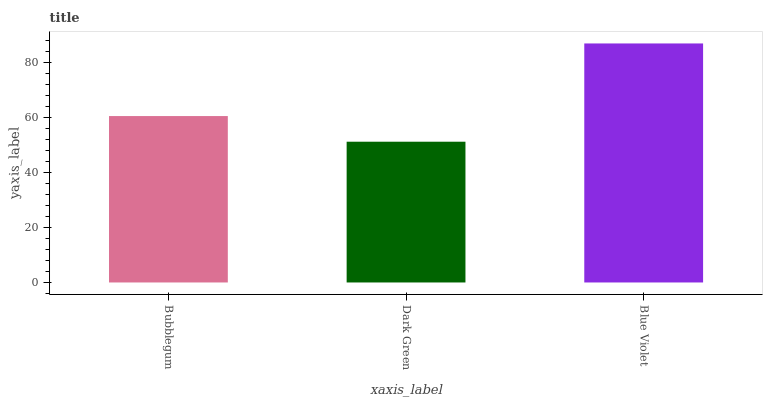Is Blue Violet the minimum?
Answer yes or no. No. Is Dark Green the maximum?
Answer yes or no. No. Is Blue Violet greater than Dark Green?
Answer yes or no. Yes. Is Dark Green less than Blue Violet?
Answer yes or no. Yes. Is Dark Green greater than Blue Violet?
Answer yes or no. No. Is Blue Violet less than Dark Green?
Answer yes or no. No. Is Bubblegum the high median?
Answer yes or no. Yes. Is Bubblegum the low median?
Answer yes or no. Yes. Is Dark Green the high median?
Answer yes or no. No. Is Dark Green the low median?
Answer yes or no. No. 